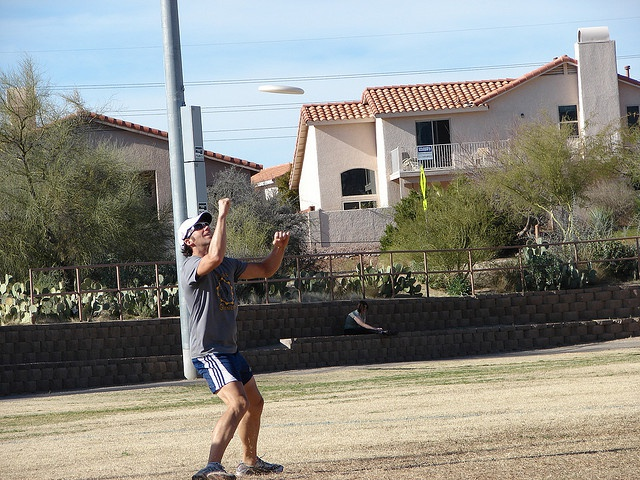Describe the objects in this image and their specific colors. I can see people in lightblue, black, maroon, lightgray, and darkgray tones, people in lightblue, black, gray, and darkgray tones, and frisbee in lightblue, white, darkgray, and tan tones in this image. 